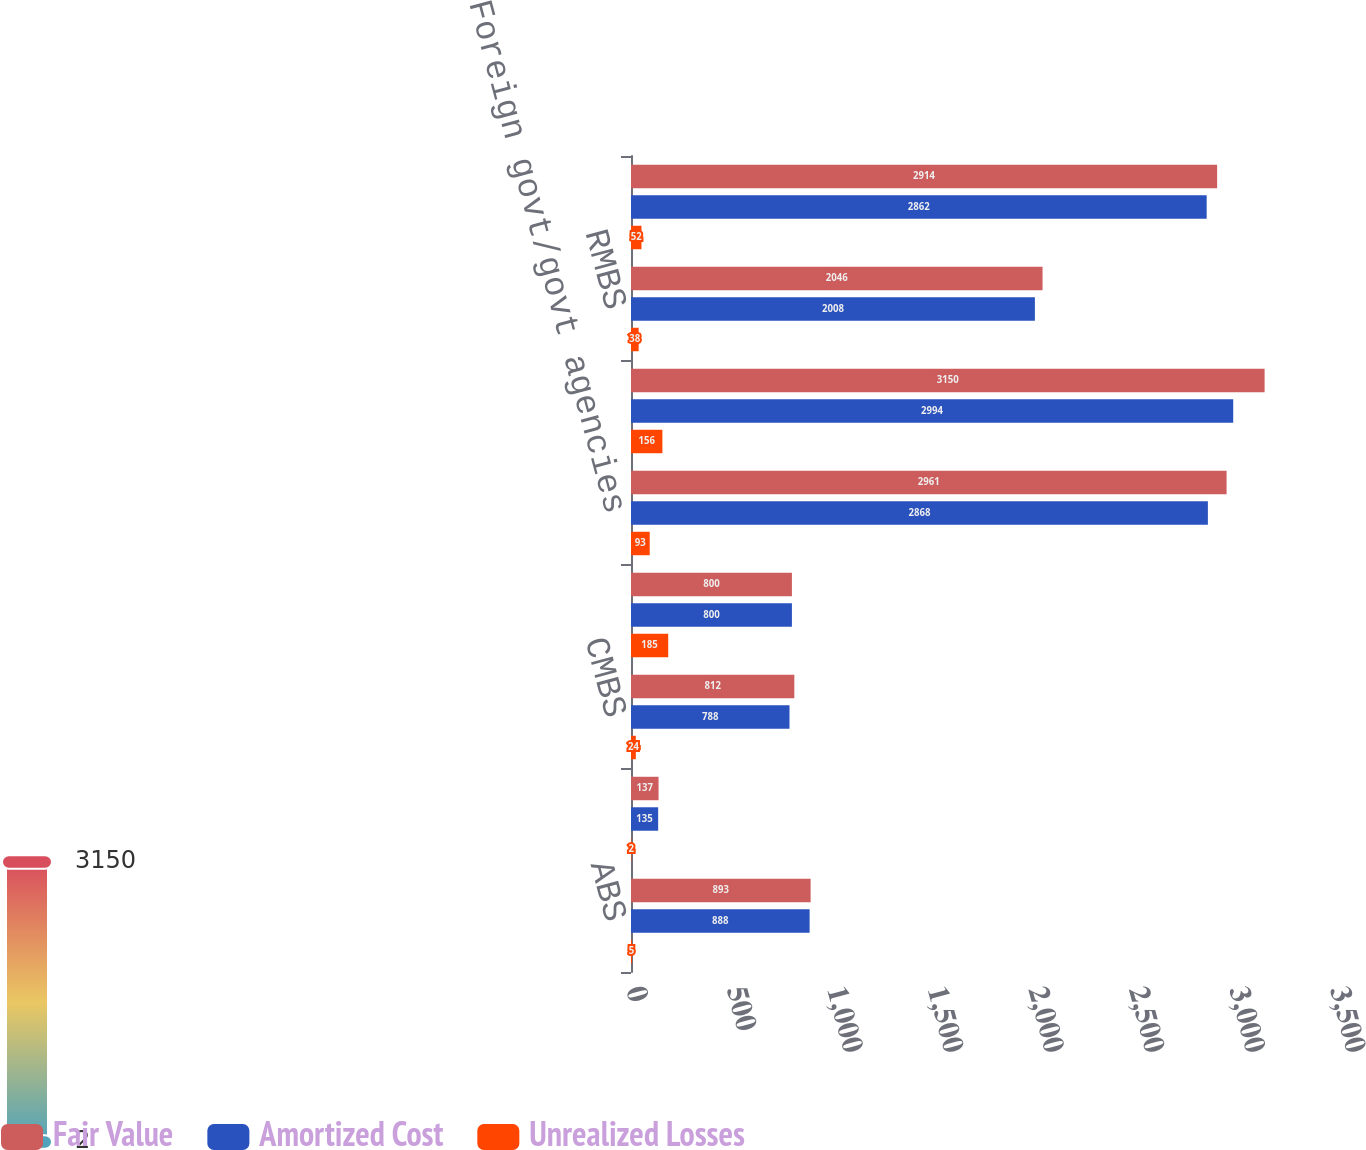Convert chart to OTSL. <chart><loc_0><loc_0><loc_500><loc_500><stacked_bar_chart><ecel><fcel>ABS<fcel>CDOs 1<fcel>CMBS<fcel>Corporate<fcel>Foreign govt/govt agencies<fcel>Municipal<fcel>RMBS<fcel>US Treasuries<nl><fcel>Fair Value<fcel>893<fcel>137<fcel>812<fcel>800<fcel>2961<fcel>3150<fcel>2046<fcel>2914<nl><fcel>Amortized Cost<fcel>888<fcel>135<fcel>788<fcel>800<fcel>2868<fcel>2994<fcel>2008<fcel>2862<nl><fcel>Unrealized Losses<fcel>5<fcel>2<fcel>24<fcel>185<fcel>93<fcel>156<fcel>38<fcel>52<nl></chart> 